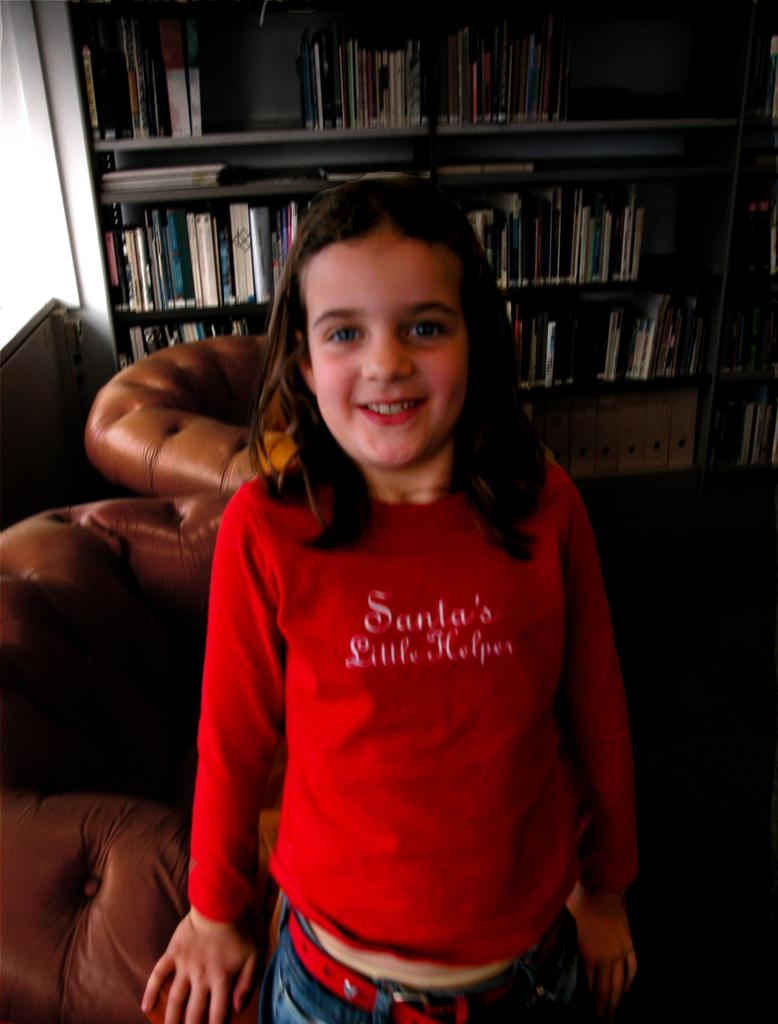<image>
Provide a brief description of the given image. A young girls stands in a dark study and is smiling while wearing  a red Santa's Little Helper sweater. 